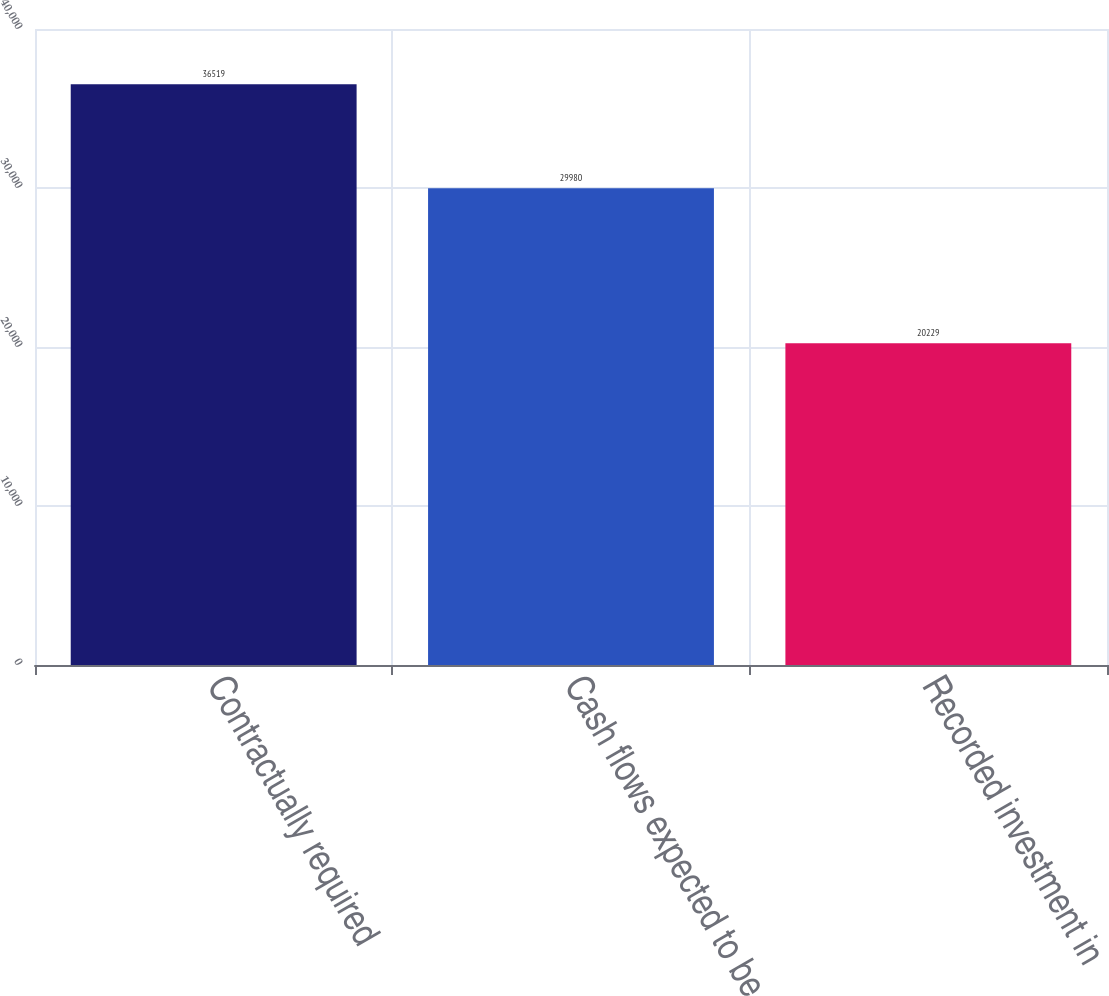Convert chart. <chart><loc_0><loc_0><loc_500><loc_500><bar_chart><fcel>Contractually required<fcel>Cash flows expected to be<fcel>Recorded investment in<nl><fcel>36519<fcel>29980<fcel>20229<nl></chart> 